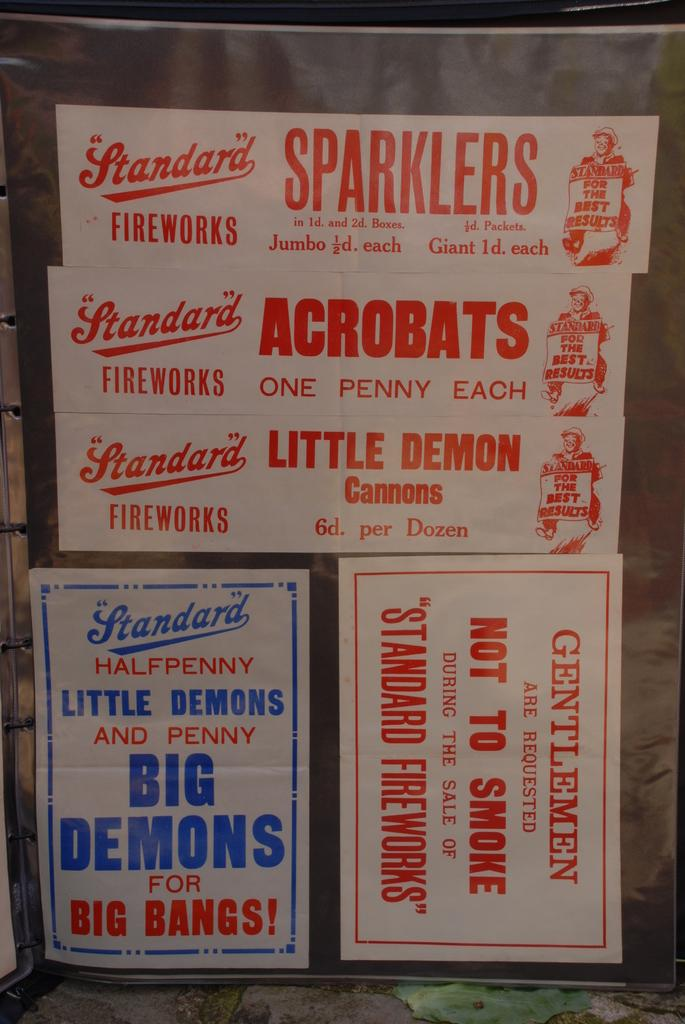<image>
Render a clear and concise summary of the photo. ONE PENNY AND HALF PENNY STANDARD FIREWORKS IN THREE CARTONS 